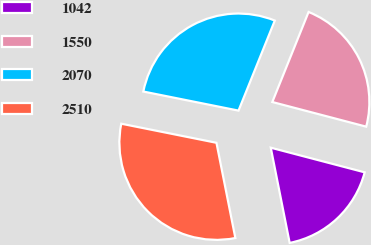Convert chart. <chart><loc_0><loc_0><loc_500><loc_500><pie_chart><fcel>1042<fcel>1550<fcel>2070<fcel>2510<nl><fcel>17.8%<fcel>22.99%<fcel>27.95%<fcel>31.27%<nl></chart> 